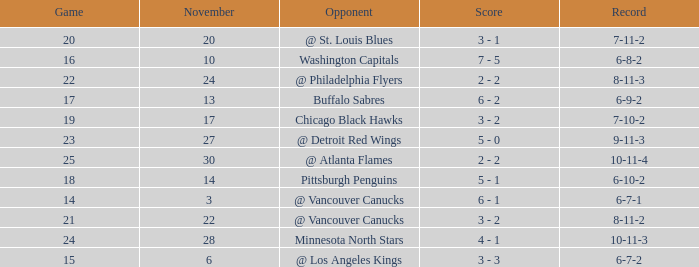Help me parse the entirety of this table. {'header': ['Game', 'November', 'Opponent', 'Score', 'Record'], 'rows': [['20', '20', '@ St. Louis Blues', '3 - 1', '7-11-2'], ['16', '10', 'Washington Capitals', '7 - 5', '6-8-2'], ['22', '24', '@ Philadelphia Flyers', '2 - 2', '8-11-3'], ['17', '13', 'Buffalo Sabres', '6 - 2', '6-9-2'], ['19', '17', 'Chicago Black Hawks', '3 - 2', '7-10-2'], ['23', '27', '@ Detroit Red Wings', '5 - 0', '9-11-3'], ['25', '30', '@ Atlanta Flames', '2 - 2', '10-11-4'], ['18', '14', 'Pittsburgh Penguins', '5 - 1', '6-10-2'], ['14', '3', '@ Vancouver Canucks', '6 - 1', '6-7-1'], ['21', '22', '@ Vancouver Canucks', '3 - 2', '8-11-2'], ['24', '28', 'Minnesota North Stars', '4 - 1', '10-11-3'], ['15', '6', '@ Los Angeles Kings', '3 - 3', '6-7-2']]} Who is the opponent on november 24? @ Philadelphia Flyers. 